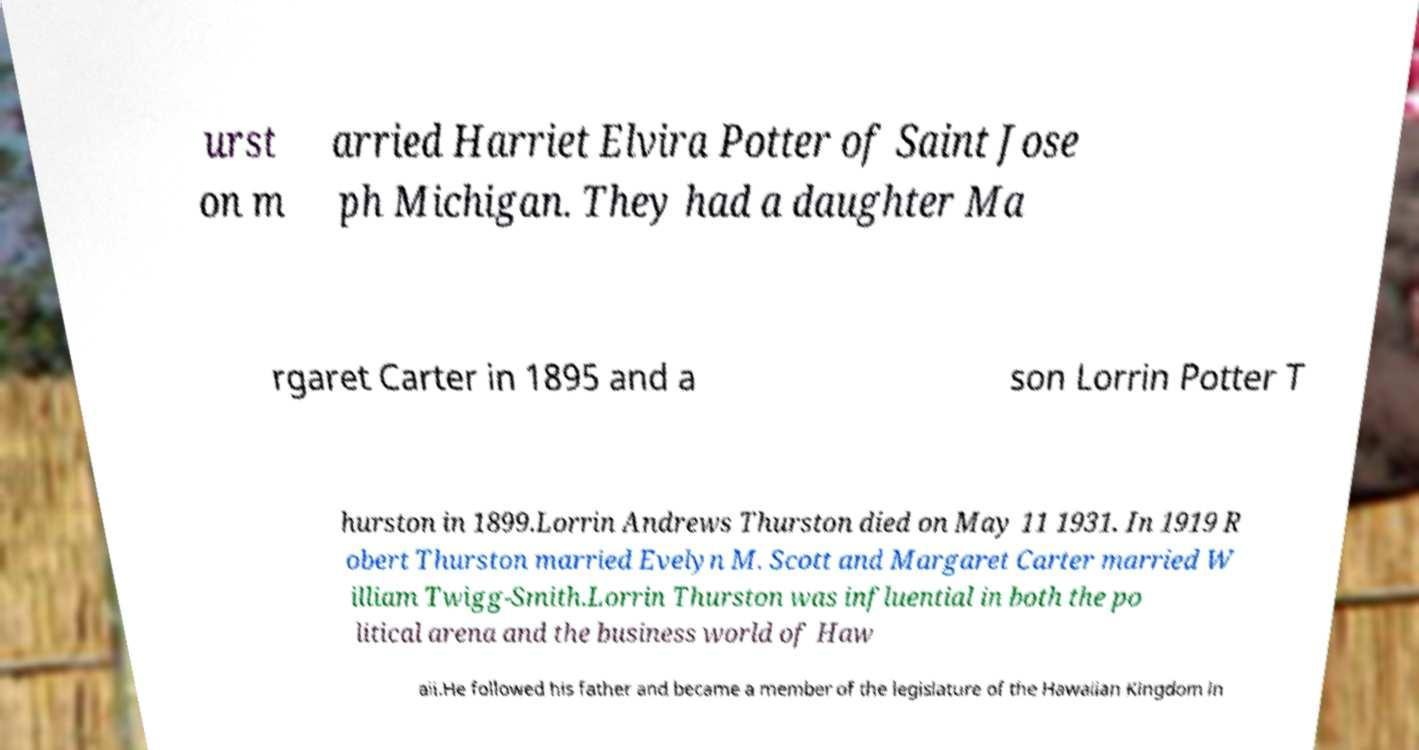There's text embedded in this image that I need extracted. Can you transcribe it verbatim? urst on m arried Harriet Elvira Potter of Saint Jose ph Michigan. They had a daughter Ma rgaret Carter in 1895 and a son Lorrin Potter T hurston in 1899.Lorrin Andrews Thurston died on May 11 1931. In 1919 R obert Thurston married Evelyn M. Scott and Margaret Carter married W illiam Twigg-Smith.Lorrin Thurston was influential in both the po litical arena and the business world of Haw aii.He followed his father and became a member of the legislature of the Hawaiian Kingdom in 